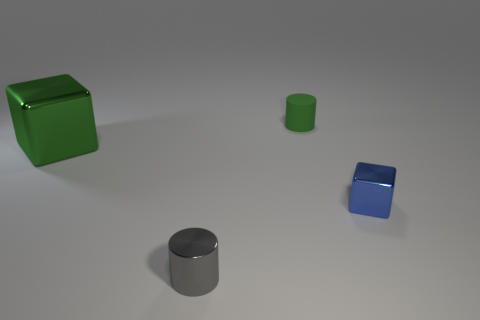There is a object that is both behind the tiny shiny block and left of the tiny rubber object; what is its shape?
Your response must be concise. Cube. Is the number of tiny green things that are to the left of the tiny shiny cylinder the same as the number of blue objects to the left of the small blue object?
Provide a short and direct response. Yes. What number of blocks are tiny brown rubber things or small gray objects?
Keep it short and to the point. 0. How many small blue blocks have the same material as the big green thing?
Make the answer very short. 1. What shape is the tiny thing that is the same color as the large shiny cube?
Make the answer very short. Cylinder. There is a small thing that is both in front of the tiny matte thing and on the left side of the small blue cube; what material is it made of?
Make the answer very short. Metal. There is a green object that is right of the gray cylinder; what shape is it?
Offer a terse response. Cylinder. What is the shape of the green object that is in front of the tiny thing behind the big green block?
Ensure brevity in your answer.  Cube. Is there another big green thing of the same shape as the big green shiny object?
Ensure brevity in your answer.  No. What is the shape of the blue shiny thing that is the same size as the rubber object?
Ensure brevity in your answer.  Cube. 